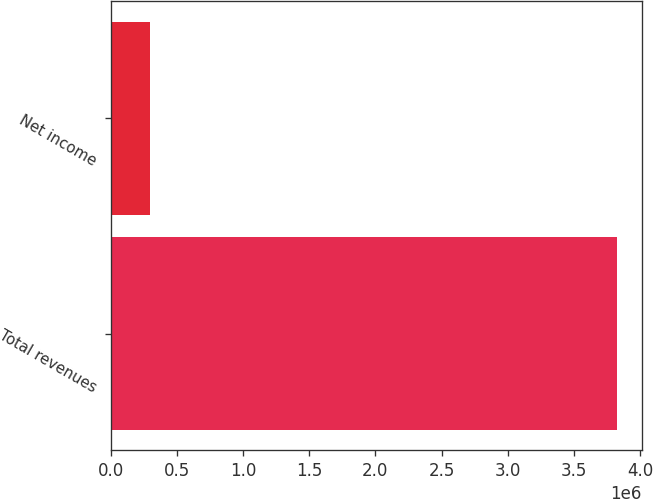Convert chart. <chart><loc_0><loc_0><loc_500><loc_500><bar_chart><fcel>Total revenues<fcel>Net income<nl><fcel>3.82376e+06<fcel>292862<nl></chart> 